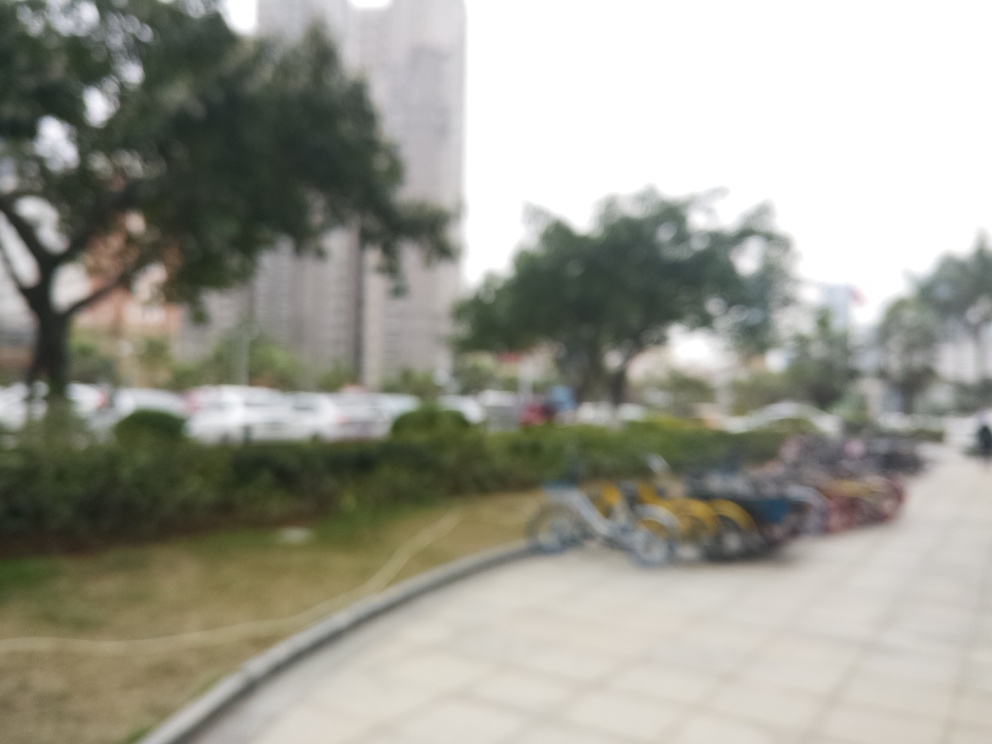Describe the atmosphere or mood that the blurriness of this photo might evoke. The blurred quality of the photo evokes a sense of mystique and ambiguity. It can also create a dreamy or nostalgic mood, as the lack of clear detail leaves much to the imagination and personal interpretation of the viewer. 